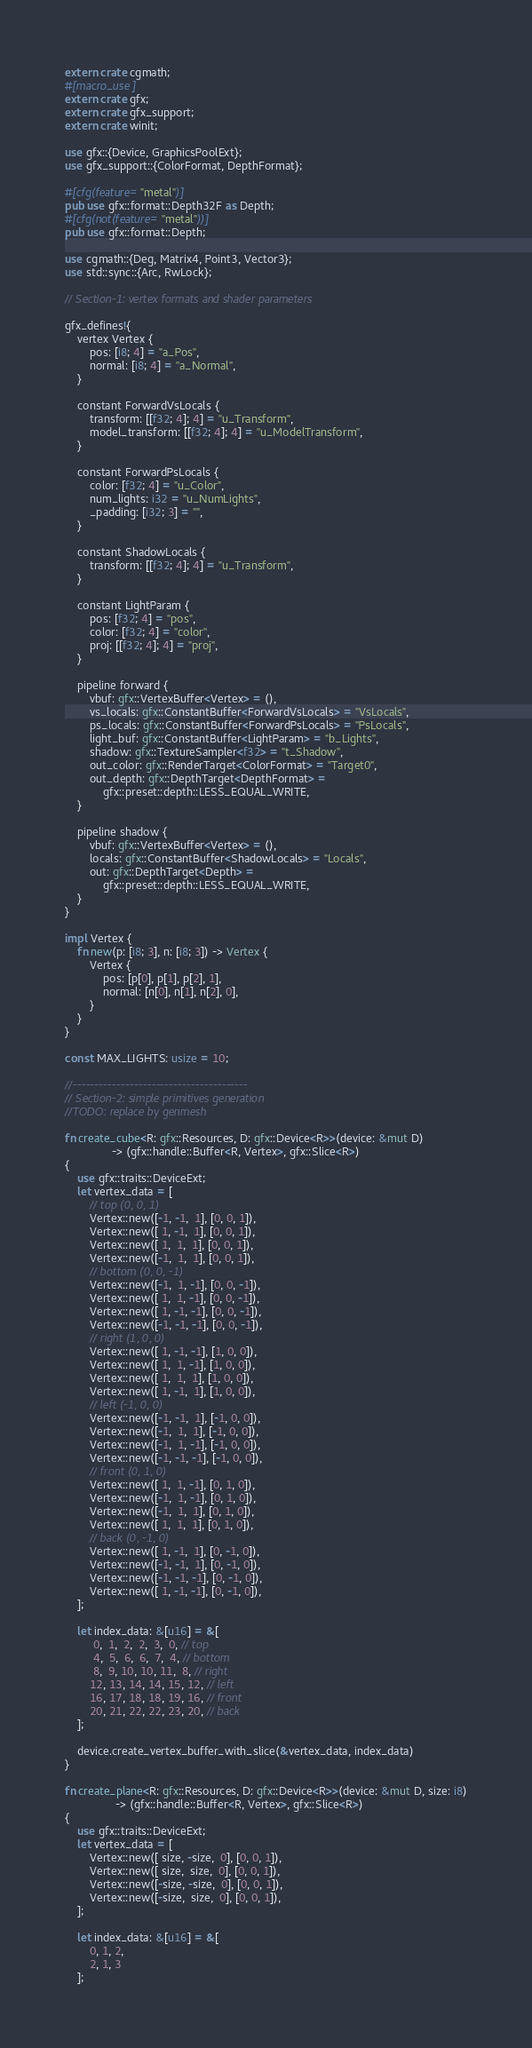Convert code to text. <code><loc_0><loc_0><loc_500><loc_500><_Rust_>extern crate cgmath;
#[macro_use]
extern crate gfx;
extern crate gfx_support;
extern crate winit;

use gfx::{Device, GraphicsPoolExt};
use gfx_support::{ColorFormat, DepthFormat};

#[cfg(feature="metal")]
pub use gfx::format::Depth32F as Depth;
#[cfg(not(feature="metal"))]
pub use gfx::format::Depth;

use cgmath::{Deg, Matrix4, Point3, Vector3};
use std::sync::{Arc, RwLock};

// Section-1: vertex formats and shader parameters

gfx_defines!{
    vertex Vertex {
        pos: [i8; 4] = "a_Pos",
        normal: [i8; 4] = "a_Normal",
    }

    constant ForwardVsLocals {
        transform: [[f32; 4]; 4] = "u_Transform",
        model_transform: [[f32; 4]; 4] = "u_ModelTransform",
    }

    constant ForwardPsLocals {
        color: [f32; 4] = "u_Color",
        num_lights: i32 = "u_NumLights",
        _padding: [i32; 3] = "",
    }

    constant ShadowLocals {
        transform: [[f32; 4]; 4] = "u_Transform",
    }

    constant LightParam {
        pos: [f32; 4] = "pos",
        color: [f32; 4] = "color",
        proj: [[f32; 4]; 4] = "proj",
    }

    pipeline forward {
        vbuf: gfx::VertexBuffer<Vertex> = (),
        vs_locals: gfx::ConstantBuffer<ForwardVsLocals> = "VsLocals",
        ps_locals: gfx::ConstantBuffer<ForwardPsLocals> = "PsLocals",
        light_buf: gfx::ConstantBuffer<LightParam> = "b_Lights",
        shadow: gfx::TextureSampler<f32> = "t_Shadow",
        out_color: gfx::RenderTarget<ColorFormat> = "Target0",
        out_depth: gfx::DepthTarget<DepthFormat> =
            gfx::preset::depth::LESS_EQUAL_WRITE,
    }

    pipeline shadow {
        vbuf: gfx::VertexBuffer<Vertex> = (),
        locals: gfx::ConstantBuffer<ShadowLocals> = "Locals",
        out: gfx::DepthTarget<Depth> =
            gfx::preset::depth::LESS_EQUAL_WRITE,
    }
}

impl Vertex {
    fn new(p: [i8; 3], n: [i8; 3]) -> Vertex {
        Vertex {
            pos: [p[0], p[1], p[2], 1],
            normal: [n[0], n[1], n[2], 0],
        }
    }
}

const MAX_LIGHTS: usize = 10;

//----------------------------------------
// Section-2: simple primitives generation
//TODO: replace by genmesh

fn create_cube<R: gfx::Resources, D: gfx::Device<R>>(device: &mut D)
               -> (gfx::handle::Buffer<R, Vertex>, gfx::Slice<R>)
{
    use gfx::traits::DeviceExt;
    let vertex_data = [
        // top (0, 0, 1)
        Vertex::new([-1, -1,  1], [0, 0, 1]),
        Vertex::new([ 1, -1,  1], [0, 0, 1]),
        Vertex::new([ 1,  1,  1], [0, 0, 1]),
        Vertex::new([-1,  1,  1], [0, 0, 1]),
        // bottom (0, 0, -1)
        Vertex::new([-1,  1, -1], [0, 0, -1]),
        Vertex::new([ 1,  1, -1], [0, 0, -1]),
        Vertex::new([ 1, -1, -1], [0, 0, -1]),
        Vertex::new([-1, -1, -1], [0, 0, -1]),
        // right (1, 0, 0)
        Vertex::new([ 1, -1, -1], [1, 0, 0]),
        Vertex::new([ 1,  1, -1], [1, 0, 0]),
        Vertex::new([ 1,  1,  1], [1, 0, 0]),
        Vertex::new([ 1, -1,  1], [1, 0, 0]),
        // left (-1, 0, 0)
        Vertex::new([-1, -1,  1], [-1, 0, 0]),
        Vertex::new([-1,  1,  1], [-1, 0, 0]),
        Vertex::new([-1,  1, -1], [-1, 0, 0]),
        Vertex::new([-1, -1, -1], [-1, 0, 0]),
        // front (0, 1, 0)
        Vertex::new([ 1,  1, -1], [0, 1, 0]),
        Vertex::new([-1,  1, -1], [0, 1, 0]),
        Vertex::new([-1,  1,  1], [0, 1, 0]),
        Vertex::new([ 1,  1,  1], [0, 1, 0]),
        // back (0, -1, 0)
        Vertex::new([ 1, -1,  1], [0, -1, 0]),
        Vertex::new([-1, -1,  1], [0, -1, 0]),
        Vertex::new([-1, -1, -1], [0, -1, 0]),
        Vertex::new([ 1, -1, -1], [0, -1, 0]),
    ];

    let index_data: &[u16] = &[
         0,  1,  2,  2,  3,  0, // top
         4,  5,  6,  6,  7,  4, // bottom
         8,  9, 10, 10, 11,  8, // right
        12, 13, 14, 14, 15, 12, // left
        16, 17, 18, 18, 19, 16, // front
        20, 21, 22, 22, 23, 20, // back
    ];

    device.create_vertex_buffer_with_slice(&vertex_data, index_data)
}

fn create_plane<R: gfx::Resources, D: gfx::Device<R>>(device: &mut D, size: i8)
                -> (gfx::handle::Buffer<R, Vertex>, gfx::Slice<R>)
{
    use gfx::traits::DeviceExt;
    let vertex_data = [
        Vertex::new([ size, -size,  0], [0, 0, 1]),
        Vertex::new([ size,  size,  0], [0, 0, 1]),
        Vertex::new([-size, -size,  0], [0, 0, 1]),
        Vertex::new([-size,  size,  0], [0, 0, 1]),
    ];

    let index_data: &[u16] = &[
        0, 1, 2,
        2, 1, 3
    ];
</code> 